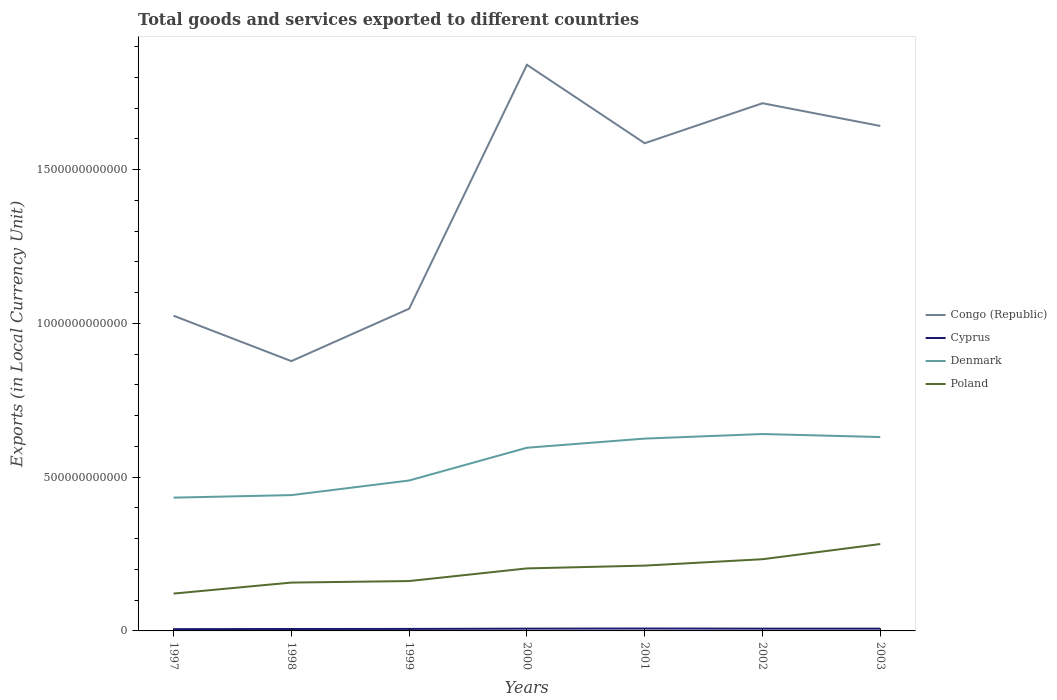How many different coloured lines are there?
Your answer should be compact. 4. Does the line corresponding to Denmark intersect with the line corresponding to Congo (Republic)?
Make the answer very short. No. Across all years, what is the maximum Amount of goods and services exports in Denmark?
Your answer should be compact. 4.33e+11. In which year was the Amount of goods and services exports in Cyprus maximum?
Make the answer very short. 1997. What is the total Amount of goods and services exports in Cyprus in the graph?
Provide a succinct answer. -1.27e+09. What is the difference between the highest and the second highest Amount of goods and services exports in Denmark?
Keep it short and to the point. 2.07e+11. What is the difference between two consecutive major ticks on the Y-axis?
Provide a succinct answer. 5.00e+11. Are the values on the major ticks of Y-axis written in scientific E-notation?
Keep it short and to the point. No. Where does the legend appear in the graph?
Provide a short and direct response. Center right. How many legend labels are there?
Your answer should be compact. 4. What is the title of the graph?
Your response must be concise. Total goods and services exported to different countries. Does "Pakistan" appear as one of the legend labels in the graph?
Ensure brevity in your answer.  No. What is the label or title of the X-axis?
Your answer should be compact. Years. What is the label or title of the Y-axis?
Offer a very short reply. Exports (in Local Currency Unit). What is the Exports (in Local Currency Unit) in Congo (Republic) in 1997?
Your answer should be very brief. 1.02e+12. What is the Exports (in Local Currency Unit) of Cyprus in 1997?
Offer a terse response. 5.79e+09. What is the Exports (in Local Currency Unit) of Denmark in 1997?
Offer a very short reply. 4.33e+11. What is the Exports (in Local Currency Unit) in Poland in 1997?
Your answer should be compact. 1.21e+11. What is the Exports (in Local Currency Unit) of Congo (Republic) in 1998?
Your answer should be very brief. 8.77e+11. What is the Exports (in Local Currency Unit) of Cyprus in 1998?
Keep it short and to the point. 6.22e+09. What is the Exports (in Local Currency Unit) in Denmark in 1998?
Your response must be concise. 4.42e+11. What is the Exports (in Local Currency Unit) of Poland in 1998?
Give a very brief answer. 1.57e+11. What is the Exports (in Local Currency Unit) in Congo (Republic) in 1999?
Provide a short and direct response. 1.05e+12. What is the Exports (in Local Currency Unit) in Cyprus in 1999?
Provide a succinct answer. 6.51e+09. What is the Exports (in Local Currency Unit) of Denmark in 1999?
Give a very brief answer. 4.89e+11. What is the Exports (in Local Currency Unit) in Poland in 1999?
Your answer should be compact. 1.62e+11. What is the Exports (in Local Currency Unit) in Congo (Republic) in 2000?
Offer a terse response. 1.84e+12. What is the Exports (in Local Currency Unit) of Cyprus in 2000?
Your answer should be very brief. 7.41e+09. What is the Exports (in Local Currency Unit) in Denmark in 2000?
Your answer should be compact. 5.96e+11. What is the Exports (in Local Currency Unit) of Poland in 2000?
Offer a very short reply. 2.03e+11. What is the Exports (in Local Currency Unit) in Congo (Republic) in 2001?
Provide a succinct answer. 1.59e+12. What is the Exports (in Local Currency Unit) in Cyprus in 2001?
Your answer should be compact. 7.79e+09. What is the Exports (in Local Currency Unit) in Denmark in 2001?
Offer a very short reply. 6.25e+11. What is the Exports (in Local Currency Unit) in Poland in 2001?
Make the answer very short. 2.12e+11. What is the Exports (in Local Currency Unit) in Congo (Republic) in 2002?
Your answer should be very brief. 1.72e+12. What is the Exports (in Local Currency Unit) in Cyprus in 2002?
Your answer should be very brief. 7.41e+09. What is the Exports (in Local Currency Unit) of Denmark in 2002?
Provide a succinct answer. 6.40e+11. What is the Exports (in Local Currency Unit) of Poland in 2002?
Your answer should be compact. 2.33e+11. What is the Exports (in Local Currency Unit) of Congo (Republic) in 2003?
Offer a terse response. 1.64e+12. What is the Exports (in Local Currency Unit) of Cyprus in 2003?
Provide a succinct answer. 7.42e+09. What is the Exports (in Local Currency Unit) of Denmark in 2003?
Make the answer very short. 6.30e+11. What is the Exports (in Local Currency Unit) in Poland in 2003?
Keep it short and to the point. 2.82e+11. Across all years, what is the maximum Exports (in Local Currency Unit) of Congo (Republic)?
Keep it short and to the point. 1.84e+12. Across all years, what is the maximum Exports (in Local Currency Unit) of Cyprus?
Offer a terse response. 7.79e+09. Across all years, what is the maximum Exports (in Local Currency Unit) of Denmark?
Your answer should be very brief. 6.40e+11. Across all years, what is the maximum Exports (in Local Currency Unit) of Poland?
Your answer should be compact. 2.82e+11. Across all years, what is the minimum Exports (in Local Currency Unit) of Congo (Republic)?
Provide a succinct answer. 8.77e+11. Across all years, what is the minimum Exports (in Local Currency Unit) of Cyprus?
Offer a terse response. 5.79e+09. Across all years, what is the minimum Exports (in Local Currency Unit) in Denmark?
Offer a terse response. 4.33e+11. Across all years, what is the minimum Exports (in Local Currency Unit) in Poland?
Make the answer very short. 1.21e+11. What is the total Exports (in Local Currency Unit) of Congo (Republic) in the graph?
Offer a terse response. 9.73e+12. What is the total Exports (in Local Currency Unit) of Cyprus in the graph?
Your response must be concise. 4.86e+1. What is the total Exports (in Local Currency Unit) in Denmark in the graph?
Offer a very short reply. 3.86e+12. What is the total Exports (in Local Currency Unit) in Poland in the graph?
Your response must be concise. 1.37e+12. What is the difference between the Exports (in Local Currency Unit) of Congo (Republic) in 1997 and that in 1998?
Your answer should be very brief. 1.48e+11. What is the difference between the Exports (in Local Currency Unit) in Cyprus in 1997 and that in 1998?
Provide a succinct answer. -4.31e+08. What is the difference between the Exports (in Local Currency Unit) in Denmark in 1997 and that in 1998?
Ensure brevity in your answer.  -8.22e+09. What is the difference between the Exports (in Local Currency Unit) in Poland in 1997 and that in 1998?
Keep it short and to the point. -3.57e+1. What is the difference between the Exports (in Local Currency Unit) of Congo (Republic) in 1997 and that in 1999?
Make the answer very short. -2.28e+1. What is the difference between the Exports (in Local Currency Unit) of Cyprus in 1997 and that in 1999?
Offer a very short reply. -7.20e+08. What is the difference between the Exports (in Local Currency Unit) of Denmark in 1997 and that in 1999?
Keep it short and to the point. -5.57e+1. What is the difference between the Exports (in Local Currency Unit) of Poland in 1997 and that in 1999?
Make the answer very short. -4.07e+1. What is the difference between the Exports (in Local Currency Unit) in Congo (Republic) in 1997 and that in 2000?
Give a very brief answer. -8.16e+11. What is the difference between the Exports (in Local Currency Unit) in Cyprus in 1997 and that in 2000?
Make the answer very short. -1.62e+09. What is the difference between the Exports (in Local Currency Unit) in Denmark in 1997 and that in 2000?
Offer a very short reply. -1.62e+11. What is the difference between the Exports (in Local Currency Unit) of Poland in 1997 and that in 2000?
Give a very brief answer. -8.18e+1. What is the difference between the Exports (in Local Currency Unit) in Congo (Republic) in 1997 and that in 2001?
Ensure brevity in your answer.  -5.61e+11. What is the difference between the Exports (in Local Currency Unit) of Cyprus in 1997 and that in 2001?
Offer a very short reply. -1.99e+09. What is the difference between the Exports (in Local Currency Unit) of Denmark in 1997 and that in 2001?
Offer a terse response. -1.92e+11. What is the difference between the Exports (in Local Currency Unit) of Poland in 1997 and that in 2001?
Offer a very short reply. -9.09e+1. What is the difference between the Exports (in Local Currency Unit) in Congo (Republic) in 1997 and that in 2002?
Keep it short and to the point. -6.91e+11. What is the difference between the Exports (in Local Currency Unit) of Cyprus in 1997 and that in 2002?
Give a very brief answer. -1.62e+09. What is the difference between the Exports (in Local Currency Unit) of Denmark in 1997 and that in 2002?
Your response must be concise. -2.07e+11. What is the difference between the Exports (in Local Currency Unit) of Poland in 1997 and that in 2002?
Your answer should be very brief. -1.12e+11. What is the difference between the Exports (in Local Currency Unit) of Congo (Republic) in 1997 and that in 2003?
Your answer should be compact. -6.17e+11. What is the difference between the Exports (in Local Currency Unit) of Cyprus in 1997 and that in 2003?
Your answer should be compact. -1.63e+09. What is the difference between the Exports (in Local Currency Unit) in Denmark in 1997 and that in 2003?
Provide a short and direct response. -1.97e+11. What is the difference between the Exports (in Local Currency Unit) in Poland in 1997 and that in 2003?
Offer a terse response. -1.61e+11. What is the difference between the Exports (in Local Currency Unit) in Congo (Republic) in 1998 and that in 1999?
Your response must be concise. -1.70e+11. What is the difference between the Exports (in Local Currency Unit) of Cyprus in 1998 and that in 1999?
Offer a very short reply. -2.89e+08. What is the difference between the Exports (in Local Currency Unit) of Denmark in 1998 and that in 1999?
Provide a succinct answer. -4.75e+1. What is the difference between the Exports (in Local Currency Unit) of Poland in 1998 and that in 1999?
Keep it short and to the point. -4.95e+09. What is the difference between the Exports (in Local Currency Unit) in Congo (Republic) in 1998 and that in 2000?
Keep it short and to the point. -9.64e+11. What is the difference between the Exports (in Local Currency Unit) of Cyprus in 1998 and that in 2000?
Offer a very short reply. -1.19e+09. What is the difference between the Exports (in Local Currency Unit) of Denmark in 1998 and that in 2000?
Your answer should be very brief. -1.54e+11. What is the difference between the Exports (in Local Currency Unit) in Poland in 1998 and that in 2000?
Your response must be concise. -4.61e+1. What is the difference between the Exports (in Local Currency Unit) in Congo (Republic) in 1998 and that in 2001?
Your answer should be very brief. -7.09e+11. What is the difference between the Exports (in Local Currency Unit) of Cyprus in 1998 and that in 2001?
Your answer should be compact. -1.56e+09. What is the difference between the Exports (in Local Currency Unit) in Denmark in 1998 and that in 2001?
Your answer should be very brief. -1.84e+11. What is the difference between the Exports (in Local Currency Unit) in Poland in 1998 and that in 2001?
Keep it short and to the point. -5.52e+1. What is the difference between the Exports (in Local Currency Unit) of Congo (Republic) in 1998 and that in 2002?
Your answer should be very brief. -8.39e+11. What is the difference between the Exports (in Local Currency Unit) in Cyprus in 1998 and that in 2002?
Your answer should be very brief. -1.19e+09. What is the difference between the Exports (in Local Currency Unit) of Denmark in 1998 and that in 2002?
Give a very brief answer. -1.99e+11. What is the difference between the Exports (in Local Currency Unit) of Poland in 1998 and that in 2002?
Provide a succinct answer. -7.59e+1. What is the difference between the Exports (in Local Currency Unit) of Congo (Republic) in 1998 and that in 2003?
Keep it short and to the point. -7.65e+11. What is the difference between the Exports (in Local Currency Unit) of Cyprus in 1998 and that in 2003?
Offer a terse response. -1.20e+09. What is the difference between the Exports (in Local Currency Unit) in Denmark in 1998 and that in 2003?
Offer a terse response. -1.89e+11. What is the difference between the Exports (in Local Currency Unit) in Poland in 1998 and that in 2003?
Make the answer very short. -1.25e+11. What is the difference between the Exports (in Local Currency Unit) in Congo (Republic) in 1999 and that in 2000?
Your response must be concise. -7.93e+11. What is the difference between the Exports (in Local Currency Unit) in Cyprus in 1999 and that in 2000?
Offer a terse response. -9.00e+08. What is the difference between the Exports (in Local Currency Unit) in Denmark in 1999 and that in 2000?
Your response must be concise. -1.07e+11. What is the difference between the Exports (in Local Currency Unit) of Poland in 1999 and that in 2000?
Your answer should be very brief. -4.11e+1. What is the difference between the Exports (in Local Currency Unit) in Congo (Republic) in 1999 and that in 2001?
Your answer should be very brief. -5.38e+11. What is the difference between the Exports (in Local Currency Unit) of Cyprus in 1999 and that in 2001?
Offer a terse response. -1.27e+09. What is the difference between the Exports (in Local Currency Unit) in Denmark in 1999 and that in 2001?
Provide a succinct answer. -1.36e+11. What is the difference between the Exports (in Local Currency Unit) of Poland in 1999 and that in 2001?
Your answer should be very brief. -5.02e+1. What is the difference between the Exports (in Local Currency Unit) in Congo (Republic) in 1999 and that in 2002?
Ensure brevity in your answer.  -6.68e+11. What is the difference between the Exports (in Local Currency Unit) in Cyprus in 1999 and that in 2002?
Make the answer very short. -8.99e+08. What is the difference between the Exports (in Local Currency Unit) of Denmark in 1999 and that in 2002?
Ensure brevity in your answer.  -1.51e+11. What is the difference between the Exports (in Local Currency Unit) of Poland in 1999 and that in 2002?
Give a very brief answer. -7.10e+1. What is the difference between the Exports (in Local Currency Unit) of Congo (Republic) in 1999 and that in 2003?
Keep it short and to the point. -5.94e+11. What is the difference between the Exports (in Local Currency Unit) of Cyprus in 1999 and that in 2003?
Ensure brevity in your answer.  -9.07e+08. What is the difference between the Exports (in Local Currency Unit) in Denmark in 1999 and that in 2003?
Your response must be concise. -1.41e+11. What is the difference between the Exports (in Local Currency Unit) of Poland in 1999 and that in 2003?
Provide a succinct answer. -1.20e+11. What is the difference between the Exports (in Local Currency Unit) of Congo (Republic) in 2000 and that in 2001?
Ensure brevity in your answer.  2.55e+11. What is the difference between the Exports (in Local Currency Unit) of Cyprus in 2000 and that in 2001?
Offer a terse response. -3.75e+08. What is the difference between the Exports (in Local Currency Unit) of Denmark in 2000 and that in 2001?
Ensure brevity in your answer.  -2.97e+1. What is the difference between the Exports (in Local Currency Unit) in Poland in 2000 and that in 2001?
Provide a short and direct response. -9.07e+09. What is the difference between the Exports (in Local Currency Unit) of Congo (Republic) in 2000 and that in 2002?
Ensure brevity in your answer.  1.25e+11. What is the difference between the Exports (in Local Currency Unit) in Cyprus in 2000 and that in 2002?
Provide a short and direct response. 6.50e+05. What is the difference between the Exports (in Local Currency Unit) in Denmark in 2000 and that in 2002?
Keep it short and to the point. -4.46e+1. What is the difference between the Exports (in Local Currency Unit) in Poland in 2000 and that in 2002?
Your answer should be very brief. -2.98e+1. What is the difference between the Exports (in Local Currency Unit) in Congo (Republic) in 2000 and that in 2003?
Give a very brief answer. 1.99e+11. What is the difference between the Exports (in Local Currency Unit) of Cyprus in 2000 and that in 2003?
Your answer should be very brief. -7.16e+06. What is the difference between the Exports (in Local Currency Unit) of Denmark in 2000 and that in 2003?
Provide a succinct answer. -3.48e+1. What is the difference between the Exports (in Local Currency Unit) in Poland in 2000 and that in 2003?
Your response must be concise. -7.92e+1. What is the difference between the Exports (in Local Currency Unit) of Congo (Republic) in 2001 and that in 2002?
Ensure brevity in your answer.  -1.30e+11. What is the difference between the Exports (in Local Currency Unit) in Cyprus in 2001 and that in 2002?
Your answer should be very brief. 3.75e+08. What is the difference between the Exports (in Local Currency Unit) in Denmark in 2001 and that in 2002?
Offer a terse response. -1.49e+1. What is the difference between the Exports (in Local Currency Unit) of Poland in 2001 and that in 2002?
Keep it short and to the point. -2.08e+1. What is the difference between the Exports (in Local Currency Unit) in Congo (Republic) in 2001 and that in 2003?
Provide a succinct answer. -5.62e+1. What is the difference between the Exports (in Local Currency Unit) of Cyprus in 2001 and that in 2003?
Your answer should be very brief. 3.68e+08. What is the difference between the Exports (in Local Currency Unit) of Denmark in 2001 and that in 2003?
Make the answer very short. -5.06e+09. What is the difference between the Exports (in Local Currency Unit) in Poland in 2001 and that in 2003?
Your response must be concise. -7.01e+1. What is the difference between the Exports (in Local Currency Unit) of Congo (Republic) in 2002 and that in 2003?
Keep it short and to the point. 7.39e+1. What is the difference between the Exports (in Local Currency Unit) in Cyprus in 2002 and that in 2003?
Offer a terse response. -7.81e+06. What is the difference between the Exports (in Local Currency Unit) of Denmark in 2002 and that in 2003?
Give a very brief answer. 9.83e+09. What is the difference between the Exports (in Local Currency Unit) of Poland in 2002 and that in 2003?
Provide a succinct answer. -4.93e+1. What is the difference between the Exports (in Local Currency Unit) in Congo (Republic) in 1997 and the Exports (in Local Currency Unit) in Cyprus in 1998?
Your answer should be very brief. 1.02e+12. What is the difference between the Exports (in Local Currency Unit) in Congo (Republic) in 1997 and the Exports (in Local Currency Unit) in Denmark in 1998?
Make the answer very short. 5.83e+11. What is the difference between the Exports (in Local Currency Unit) of Congo (Republic) in 1997 and the Exports (in Local Currency Unit) of Poland in 1998?
Your response must be concise. 8.68e+11. What is the difference between the Exports (in Local Currency Unit) in Cyprus in 1997 and the Exports (in Local Currency Unit) in Denmark in 1998?
Offer a terse response. -4.36e+11. What is the difference between the Exports (in Local Currency Unit) of Cyprus in 1997 and the Exports (in Local Currency Unit) of Poland in 1998?
Ensure brevity in your answer.  -1.51e+11. What is the difference between the Exports (in Local Currency Unit) in Denmark in 1997 and the Exports (in Local Currency Unit) in Poland in 1998?
Your response must be concise. 2.76e+11. What is the difference between the Exports (in Local Currency Unit) of Congo (Republic) in 1997 and the Exports (in Local Currency Unit) of Cyprus in 1999?
Give a very brief answer. 1.02e+12. What is the difference between the Exports (in Local Currency Unit) in Congo (Republic) in 1997 and the Exports (in Local Currency Unit) in Denmark in 1999?
Provide a short and direct response. 5.36e+11. What is the difference between the Exports (in Local Currency Unit) of Congo (Republic) in 1997 and the Exports (in Local Currency Unit) of Poland in 1999?
Your response must be concise. 8.63e+11. What is the difference between the Exports (in Local Currency Unit) of Cyprus in 1997 and the Exports (in Local Currency Unit) of Denmark in 1999?
Provide a short and direct response. -4.83e+11. What is the difference between the Exports (in Local Currency Unit) of Cyprus in 1997 and the Exports (in Local Currency Unit) of Poland in 1999?
Your response must be concise. -1.56e+11. What is the difference between the Exports (in Local Currency Unit) in Denmark in 1997 and the Exports (in Local Currency Unit) in Poland in 1999?
Give a very brief answer. 2.71e+11. What is the difference between the Exports (in Local Currency Unit) in Congo (Republic) in 1997 and the Exports (in Local Currency Unit) in Cyprus in 2000?
Your answer should be compact. 1.02e+12. What is the difference between the Exports (in Local Currency Unit) in Congo (Republic) in 1997 and the Exports (in Local Currency Unit) in Denmark in 2000?
Ensure brevity in your answer.  4.29e+11. What is the difference between the Exports (in Local Currency Unit) in Congo (Republic) in 1997 and the Exports (in Local Currency Unit) in Poland in 2000?
Provide a succinct answer. 8.22e+11. What is the difference between the Exports (in Local Currency Unit) in Cyprus in 1997 and the Exports (in Local Currency Unit) in Denmark in 2000?
Provide a short and direct response. -5.90e+11. What is the difference between the Exports (in Local Currency Unit) in Cyprus in 1997 and the Exports (in Local Currency Unit) in Poland in 2000?
Provide a short and direct response. -1.97e+11. What is the difference between the Exports (in Local Currency Unit) of Denmark in 1997 and the Exports (in Local Currency Unit) of Poland in 2000?
Keep it short and to the point. 2.30e+11. What is the difference between the Exports (in Local Currency Unit) in Congo (Republic) in 1997 and the Exports (in Local Currency Unit) in Cyprus in 2001?
Provide a short and direct response. 1.02e+12. What is the difference between the Exports (in Local Currency Unit) in Congo (Republic) in 1997 and the Exports (in Local Currency Unit) in Denmark in 2001?
Keep it short and to the point. 4.00e+11. What is the difference between the Exports (in Local Currency Unit) of Congo (Republic) in 1997 and the Exports (in Local Currency Unit) of Poland in 2001?
Your response must be concise. 8.13e+11. What is the difference between the Exports (in Local Currency Unit) of Cyprus in 1997 and the Exports (in Local Currency Unit) of Denmark in 2001?
Your answer should be compact. -6.20e+11. What is the difference between the Exports (in Local Currency Unit) in Cyprus in 1997 and the Exports (in Local Currency Unit) in Poland in 2001?
Provide a short and direct response. -2.07e+11. What is the difference between the Exports (in Local Currency Unit) of Denmark in 1997 and the Exports (in Local Currency Unit) of Poland in 2001?
Give a very brief answer. 2.21e+11. What is the difference between the Exports (in Local Currency Unit) in Congo (Republic) in 1997 and the Exports (in Local Currency Unit) in Cyprus in 2002?
Your response must be concise. 1.02e+12. What is the difference between the Exports (in Local Currency Unit) of Congo (Republic) in 1997 and the Exports (in Local Currency Unit) of Denmark in 2002?
Offer a terse response. 3.85e+11. What is the difference between the Exports (in Local Currency Unit) of Congo (Republic) in 1997 and the Exports (in Local Currency Unit) of Poland in 2002?
Offer a very short reply. 7.92e+11. What is the difference between the Exports (in Local Currency Unit) in Cyprus in 1997 and the Exports (in Local Currency Unit) in Denmark in 2002?
Give a very brief answer. -6.34e+11. What is the difference between the Exports (in Local Currency Unit) in Cyprus in 1997 and the Exports (in Local Currency Unit) in Poland in 2002?
Offer a terse response. -2.27e+11. What is the difference between the Exports (in Local Currency Unit) of Denmark in 1997 and the Exports (in Local Currency Unit) of Poland in 2002?
Your response must be concise. 2.00e+11. What is the difference between the Exports (in Local Currency Unit) in Congo (Republic) in 1997 and the Exports (in Local Currency Unit) in Cyprus in 2003?
Provide a succinct answer. 1.02e+12. What is the difference between the Exports (in Local Currency Unit) in Congo (Republic) in 1997 and the Exports (in Local Currency Unit) in Denmark in 2003?
Your response must be concise. 3.94e+11. What is the difference between the Exports (in Local Currency Unit) in Congo (Republic) in 1997 and the Exports (in Local Currency Unit) in Poland in 2003?
Make the answer very short. 7.42e+11. What is the difference between the Exports (in Local Currency Unit) in Cyprus in 1997 and the Exports (in Local Currency Unit) in Denmark in 2003?
Provide a short and direct response. -6.25e+11. What is the difference between the Exports (in Local Currency Unit) of Cyprus in 1997 and the Exports (in Local Currency Unit) of Poland in 2003?
Keep it short and to the point. -2.77e+11. What is the difference between the Exports (in Local Currency Unit) in Denmark in 1997 and the Exports (in Local Currency Unit) in Poland in 2003?
Make the answer very short. 1.51e+11. What is the difference between the Exports (in Local Currency Unit) in Congo (Republic) in 1998 and the Exports (in Local Currency Unit) in Cyprus in 1999?
Make the answer very short. 8.71e+11. What is the difference between the Exports (in Local Currency Unit) in Congo (Republic) in 1998 and the Exports (in Local Currency Unit) in Denmark in 1999?
Your answer should be compact. 3.88e+11. What is the difference between the Exports (in Local Currency Unit) in Congo (Republic) in 1998 and the Exports (in Local Currency Unit) in Poland in 1999?
Your answer should be very brief. 7.15e+11. What is the difference between the Exports (in Local Currency Unit) in Cyprus in 1998 and the Exports (in Local Currency Unit) in Denmark in 1999?
Your answer should be compact. -4.83e+11. What is the difference between the Exports (in Local Currency Unit) of Cyprus in 1998 and the Exports (in Local Currency Unit) of Poland in 1999?
Your answer should be very brief. -1.56e+11. What is the difference between the Exports (in Local Currency Unit) of Denmark in 1998 and the Exports (in Local Currency Unit) of Poland in 1999?
Your response must be concise. 2.79e+11. What is the difference between the Exports (in Local Currency Unit) in Congo (Republic) in 1998 and the Exports (in Local Currency Unit) in Cyprus in 2000?
Your response must be concise. 8.70e+11. What is the difference between the Exports (in Local Currency Unit) in Congo (Republic) in 1998 and the Exports (in Local Currency Unit) in Denmark in 2000?
Your response must be concise. 2.82e+11. What is the difference between the Exports (in Local Currency Unit) of Congo (Republic) in 1998 and the Exports (in Local Currency Unit) of Poland in 2000?
Keep it short and to the point. 6.74e+11. What is the difference between the Exports (in Local Currency Unit) in Cyprus in 1998 and the Exports (in Local Currency Unit) in Denmark in 2000?
Provide a succinct answer. -5.89e+11. What is the difference between the Exports (in Local Currency Unit) of Cyprus in 1998 and the Exports (in Local Currency Unit) of Poland in 2000?
Ensure brevity in your answer.  -1.97e+11. What is the difference between the Exports (in Local Currency Unit) of Denmark in 1998 and the Exports (in Local Currency Unit) of Poland in 2000?
Give a very brief answer. 2.38e+11. What is the difference between the Exports (in Local Currency Unit) of Congo (Republic) in 1998 and the Exports (in Local Currency Unit) of Cyprus in 2001?
Your response must be concise. 8.69e+11. What is the difference between the Exports (in Local Currency Unit) in Congo (Republic) in 1998 and the Exports (in Local Currency Unit) in Denmark in 2001?
Your answer should be very brief. 2.52e+11. What is the difference between the Exports (in Local Currency Unit) of Congo (Republic) in 1998 and the Exports (in Local Currency Unit) of Poland in 2001?
Offer a terse response. 6.65e+11. What is the difference between the Exports (in Local Currency Unit) in Cyprus in 1998 and the Exports (in Local Currency Unit) in Denmark in 2001?
Provide a succinct answer. -6.19e+11. What is the difference between the Exports (in Local Currency Unit) in Cyprus in 1998 and the Exports (in Local Currency Unit) in Poland in 2001?
Offer a terse response. -2.06e+11. What is the difference between the Exports (in Local Currency Unit) of Denmark in 1998 and the Exports (in Local Currency Unit) of Poland in 2001?
Give a very brief answer. 2.29e+11. What is the difference between the Exports (in Local Currency Unit) of Congo (Republic) in 1998 and the Exports (in Local Currency Unit) of Cyprus in 2002?
Offer a very short reply. 8.70e+11. What is the difference between the Exports (in Local Currency Unit) in Congo (Republic) in 1998 and the Exports (in Local Currency Unit) in Denmark in 2002?
Offer a terse response. 2.37e+11. What is the difference between the Exports (in Local Currency Unit) in Congo (Republic) in 1998 and the Exports (in Local Currency Unit) in Poland in 2002?
Keep it short and to the point. 6.44e+11. What is the difference between the Exports (in Local Currency Unit) of Cyprus in 1998 and the Exports (in Local Currency Unit) of Denmark in 2002?
Make the answer very short. -6.34e+11. What is the difference between the Exports (in Local Currency Unit) in Cyprus in 1998 and the Exports (in Local Currency Unit) in Poland in 2002?
Your answer should be very brief. -2.27e+11. What is the difference between the Exports (in Local Currency Unit) of Denmark in 1998 and the Exports (in Local Currency Unit) of Poland in 2002?
Offer a very short reply. 2.08e+11. What is the difference between the Exports (in Local Currency Unit) of Congo (Republic) in 1998 and the Exports (in Local Currency Unit) of Cyprus in 2003?
Your response must be concise. 8.70e+11. What is the difference between the Exports (in Local Currency Unit) in Congo (Republic) in 1998 and the Exports (in Local Currency Unit) in Denmark in 2003?
Your response must be concise. 2.47e+11. What is the difference between the Exports (in Local Currency Unit) of Congo (Republic) in 1998 and the Exports (in Local Currency Unit) of Poland in 2003?
Provide a short and direct response. 5.95e+11. What is the difference between the Exports (in Local Currency Unit) of Cyprus in 1998 and the Exports (in Local Currency Unit) of Denmark in 2003?
Your response must be concise. -6.24e+11. What is the difference between the Exports (in Local Currency Unit) of Cyprus in 1998 and the Exports (in Local Currency Unit) of Poland in 2003?
Provide a succinct answer. -2.76e+11. What is the difference between the Exports (in Local Currency Unit) of Denmark in 1998 and the Exports (in Local Currency Unit) of Poland in 2003?
Give a very brief answer. 1.59e+11. What is the difference between the Exports (in Local Currency Unit) of Congo (Republic) in 1999 and the Exports (in Local Currency Unit) of Cyprus in 2000?
Provide a short and direct response. 1.04e+12. What is the difference between the Exports (in Local Currency Unit) in Congo (Republic) in 1999 and the Exports (in Local Currency Unit) in Denmark in 2000?
Your answer should be compact. 4.52e+11. What is the difference between the Exports (in Local Currency Unit) in Congo (Republic) in 1999 and the Exports (in Local Currency Unit) in Poland in 2000?
Offer a terse response. 8.44e+11. What is the difference between the Exports (in Local Currency Unit) in Cyprus in 1999 and the Exports (in Local Currency Unit) in Denmark in 2000?
Give a very brief answer. -5.89e+11. What is the difference between the Exports (in Local Currency Unit) of Cyprus in 1999 and the Exports (in Local Currency Unit) of Poland in 2000?
Your answer should be very brief. -1.97e+11. What is the difference between the Exports (in Local Currency Unit) of Denmark in 1999 and the Exports (in Local Currency Unit) of Poland in 2000?
Your answer should be compact. 2.86e+11. What is the difference between the Exports (in Local Currency Unit) in Congo (Republic) in 1999 and the Exports (in Local Currency Unit) in Cyprus in 2001?
Offer a terse response. 1.04e+12. What is the difference between the Exports (in Local Currency Unit) of Congo (Republic) in 1999 and the Exports (in Local Currency Unit) of Denmark in 2001?
Your response must be concise. 4.22e+11. What is the difference between the Exports (in Local Currency Unit) in Congo (Republic) in 1999 and the Exports (in Local Currency Unit) in Poland in 2001?
Make the answer very short. 8.35e+11. What is the difference between the Exports (in Local Currency Unit) in Cyprus in 1999 and the Exports (in Local Currency Unit) in Denmark in 2001?
Offer a terse response. -6.19e+11. What is the difference between the Exports (in Local Currency Unit) in Cyprus in 1999 and the Exports (in Local Currency Unit) in Poland in 2001?
Ensure brevity in your answer.  -2.06e+11. What is the difference between the Exports (in Local Currency Unit) of Denmark in 1999 and the Exports (in Local Currency Unit) of Poland in 2001?
Give a very brief answer. 2.77e+11. What is the difference between the Exports (in Local Currency Unit) in Congo (Republic) in 1999 and the Exports (in Local Currency Unit) in Cyprus in 2002?
Provide a short and direct response. 1.04e+12. What is the difference between the Exports (in Local Currency Unit) of Congo (Republic) in 1999 and the Exports (in Local Currency Unit) of Denmark in 2002?
Give a very brief answer. 4.07e+11. What is the difference between the Exports (in Local Currency Unit) in Congo (Republic) in 1999 and the Exports (in Local Currency Unit) in Poland in 2002?
Ensure brevity in your answer.  8.15e+11. What is the difference between the Exports (in Local Currency Unit) of Cyprus in 1999 and the Exports (in Local Currency Unit) of Denmark in 2002?
Give a very brief answer. -6.34e+11. What is the difference between the Exports (in Local Currency Unit) in Cyprus in 1999 and the Exports (in Local Currency Unit) in Poland in 2002?
Your response must be concise. -2.27e+11. What is the difference between the Exports (in Local Currency Unit) of Denmark in 1999 and the Exports (in Local Currency Unit) of Poland in 2002?
Your response must be concise. 2.56e+11. What is the difference between the Exports (in Local Currency Unit) in Congo (Republic) in 1999 and the Exports (in Local Currency Unit) in Cyprus in 2003?
Provide a short and direct response. 1.04e+12. What is the difference between the Exports (in Local Currency Unit) of Congo (Republic) in 1999 and the Exports (in Local Currency Unit) of Denmark in 2003?
Keep it short and to the point. 4.17e+11. What is the difference between the Exports (in Local Currency Unit) in Congo (Republic) in 1999 and the Exports (in Local Currency Unit) in Poland in 2003?
Your response must be concise. 7.65e+11. What is the difference between the Exports (in Local Currency Unit) in Cyprus in 1999 and the Exports (in Local Currency Unit) in Denmark in 2003?
Ensure brevity in your answer.  -6.24e+11. What is the difference between the Exports (in Local Currency Unit) in Cyprus in 1999 and the Exports (in Local Currency Unit) in Poland in 2003?
Give a very brief answer. -2.76e+11. What is the difference between the Exports (in Local Currency Unit) of Denmark in 1999 and the Exports (in Local Currency Unit) of Poland in 2003?
Offer a terse response. 2.07e+11. What is the difference between the Exports (in Local Currency Unit) of Congo (Republic) in 2000 and the Exports (in Local Currency Unit) of Cyprus in 2001?
Offer a terse response. 1.83e+12. What is the difference between the Exports (in Local Currency Unit) of Congo (Republic) in 2000 and the Exports (in Local Currency Unit) of Denmark in 2001?
Provide a short and direct response. 1.22e+12. What is the difference between the Exports (in Local Currency Unit) in Congo (Republic) in 2000 and the Exports (in Local Currency Unit) in Poland in 2001?
Your response must be concise. 1.63e+12. What is the difference between the Exports (in Local Currency Unit) in Cyprus in 2000 and the Exports (in Local Currency Unit) in Denmark in 2001?
Provide a succinct answer. -6.18e+11. What is the difference between the Exports (in Local Currency Unit) of Cyprus in 2000 and the Exports (in Local Currency Unit) of Poland in 2001?
Provide a succinct answer. -2.05e+11. What is the difference between the Exports (in Local Currency Unit) in Denmark in 2000 and the Exports (in Local Currency Unit) in Poland in 2001?
Make the answer very short. 3.83e+11. What is the difference between the Exports (in Local Currency Unit) in Congo (Republic) in 2000 and the Exports (in Local Currency Unit) in Cyprus in 2002?
Keep it short and to the point. 1.83e+12. What is the difference between the Exports (in Local Currency Unit) in Congo (Republic) in 2000 and the Exports (in Local Currency Unit) in Denmark in 2002?
Provide a short and direct response. 1.20e+12. What is the difference between the Exports (in Local Currency Unit) of Congo (Republic) in 2000 and the Exports (in Local Currency Unit) of Poland in 2002?
Provide a short and direct response. 1.61e+12. What is the difference between the Exports (in Local Currency Unit) in Cyprus in 2000 and the Exports (in Local Currency Unit) in Denmark in 2002?
Offer a terse response. -6.33e+11. What is the difference between the Exports (in Local Currency Unit) of Cyprus in 2000 and the Exports (in Local Currency Unit) of Poland in 2002?
Keep it short and to the point. -2.26e+11. What is the difference between the Exports (in Local Currency Unit) in Denmark in 2000 and the Exports (in Local Currency Unit) in Poland in 2002?
Ensure brevity in your answer.  3.63e+11. What is the difference between the Exports (in Local Currency Unit) of Congo (Republic) in 2000 and the Exports (in Local Currency Unit) of Cyprus in 2003?
Give a very brief answer. 1.83e+12. What is the difference between the Exports (in Local Currency Unit) in Congo (Republic) in 2000 and the Exports (in Local Currency Unit) in Denmark in 2003?
Offer a terse response. 1.21e+12. What is the difference between the Exports (in Local Currency Unit) of Congo (Republic) in 2000 and the Exports (in Local Currency Unit) of Poland in 2003?
Offer a terse response. 1.56e+12. What is the difference between the Exports (in Local Currency Unit) of Cyprus in 2000 and the Exports (in Local Currency Unit) of Denmark in 2003?
Provide a short and direct response. -6.23e+11. What is the difference between the Exports (in Local Currency Unit) of Cyprus in 2000 and the Exports (in Local Currency Unit) of Poland in 2003?
Give a very brief answer. -2.75e+11. What is the difference between the Exports (in Local Currency Unit) in Denmark in 2000 and the Exports (in Local Currency Unit) in Poland in 2003?
Give a very brief answer. 3.13e+11. What is the difference between the Exports (in Local Currency Unit) in Congo (Republic) in 2001 and the Exports (in Local Currency Unit) in Cyprus in 2002?
Your answer should be compact. 1.58e+12. What is the difference between the Exports (in Local Currency Unit) in Congo (Republic) in 2001 and the Exports (in Local Currency Unit) in Denmark in 2002?
Provide a succinct answer. 9.46e+11. What is the difference between the Exports (in Local Currency Unit) of Congo (Republic) in 2001 and the Exports (in Local Currency Unit) of Poland in 2002?
Ensure brevity in your answer.  1.35e+12. What is the difference between the Exports (in Local Currency Unit) of Cyprus in 2001 and the Exports (in Local Currency Unit) of Denmark in 2002?
Provide a short and direct response. -6.32e+11. What is the difference between the Exports (in Local Currency Unit) of Cyprus in 2001 and the Exports (in Local Currency Unit) of Poland in 2002?
Ensure brevity in your answer.  -2.25e+11. What is the difference between the Exports (in Local Currency Unit) in Denmark in 2001 and the Exports (in Local Currency Unit) in Poland in 2002?
Ensure brevity in your answer.  3.92e+11. What is the difference between the Exports (in Local Currency Unit) in Congo (Republic) in 2001 and the Exports (in Local Currency Unit) in Cyprus in 2003?
Ensure brevity in your answer.  1.58e+12. What is the difference between the Exports (in Local Currency Unit) of Congo (Republic) in 2001 and the Exports (in Local Currency Unit) of Denmark in 2003?
Your answer should be very brief. 9.55e+11. What is the difference between the Exports (in Local Currency Unit) in Congo (Republic) in 2001 and the Exports (in Local Currency Unit) in Poland in 2003?
Your response must be concise. 1.30e+12. What is the difference between the Exports (in Local Currency Unit) of Cyprus in 2001 and the Exports (in Local Currency Unit) of Denmark in 2003?
Offer a terse response. -6.23e+11. What is the difference between the Exports (in Local Currency Unit) in Cyprus in 2001 and the Exports (in Local Currency Unit) in Poland in 2003?
Your response must be concise. -2.75e+11. What is the difference between the Exports (in Local Currency Unit) of Denmark in 2001 and the Exports (in Local Currency Unit) of Poland in 2003?
Provide a succinct answer. 3.43e+11. What is the difference between the Exports (in Local Currency Unit) in Congo (Republic) in 2002 and the Exports (in Local Currency Unit) in Cyprus in 2003?
Keep it short and to the point. 1.71e+12. What is the difference between the Exports (in Local Currency Unit) in Congo (Republic) in 2002 and the Exports (in Local Currency Unit) in Denmark in 2003?
Give a very brief answer. 1.09e+12. What is the difference between the Exports (in Local Currency Unit) in Congo (Republic) in 2002 and the Exports (in Local Currency Unit) in Poland in 2003?
Your answer should be very brief. 1.43e+12. What is the difference between the Exports (in Local Currency Unit) of Cyprus in 2002 and the Exports (in Local Currency Unit) of Denmark in 2003?
Your response must be concise. -6.23e+11. What is the difference between the Exports (in Local Currency Unit) of Cyprus in 2002 and the Exports (in Local Currency Unit) of Poland in 2003?
Your response must be concise. -2.75e+11. What is the difference between the Exports (in Local Currency Unit) of Denmark in 2002 and the Exports (in Local Currency Unit) of Poland in 2003?
Your answer should be compact. 3.58e+11. What is the average Exports (in Local Currency Unit) of Congo (Republic) per year?
Make the answer very short. 1.39e+12. What is the average Exports (in Local Currency Unit) of Cyprus per year?
Provide a succinct answer. 6.94e+09. What is the average Exports (in Local Currency Unit) of Denmark per year?
Keep it short and to the point. 5.51e+11. What is the average Exports (in Local Currency Unit) of Poland per year?
Provide a succinct answer. 1.96e+11. In the year 1997, what is the difference between the Exports (in Local Currency Unit) in Congo (Republic) and Exports (in Local Currency Unit) in Cyprus?
Provide a short and direct response. 1.02e+12. In the year 1997, what is the difference between the Exports (in Local Currency Unit) in Congo (Republic) and Exports (in Local Currency Unit) in Denmark?
Make the answer very short. 5.91e+11. In the year 1997, what is the difference between the Exports (in Local Currency Unit) of Congo (Republic) and Exports (in Local Currency Unit) of Poland?
Your answer should be very brief. 9.03e+11. In the year 1997, what is the difference between the Exports (in Local Currency Unit) in Cyprus and Exports (in Local Currency Unit) in Denmark?
Offer a very short reply. -4.28e+11. In the year 1997, what is the difference between the Exports (in Local Currency Unit) in Cyprus and Exports (in Local Currency Unit) in Poland?
Offer a very short reply. -1.16e+11. In the year 1997, what is the difference between the Exports (in Local Currency Unit) in Denmark and Exports (in Local Currency Unit) in Poland?
Offer a terse response. 3.12e+11. In the year 1998, what is the difference between the Exports (in Local Currency Unit) in Congo (Republic) and Exports (in Local Currency Unit) in Cyprus?
Keep it short and to the point. 8.71e+11. In the year 1998, what is the difference between the Exports (in Local Currency Unit) in Congo (Republic) and Exports (in Local Currency Unit) in Denmark?
Offer a very short reply. 4.36e+11. In the year 1998, what is the difference between the Exports (in Local Currency Unit) of Congo (Republic) and Exports (in Local Currency Unit) of Poland?
Offer a terse response. 7.20e+11. In the year 1998, what is the difference between the Exports (in Local Currency Unit) in Cyprus and Exports (in Local Currency Unit) in Denmark?
Offer a very short reply. -4.35e+11. In the year 1998, what is the difference between the Exports (in Local Currency Unit) in Cyprus and Exports (in Local Currency Unit) in Poland?
Offer a terse response. -1.51e+11. In the year 1998, what is the difference between the Exports (in Local Currency Unit) in Denmark and Exports (in Local Currency Unit) in Poland?
Keep it short and to the point. 2.84e+11. In the year 1999, what is the difference between the Exports (in Local Currency Unit) in Congo (Republic) and Exports (in Local Currency Unit) in Cyprus?
Give a very brief answer. 1.04e+12. In the year 1999, what is the difference between the Exports (in Local Currency Unit) of Congo (Republic) and Exports (in Local Currency Unit) of Denmark?
Ensure brevity in your answer.  5.59e+11. In the year 1999, what is the difference between the Exports (in Local Currency Unit) in Congo (Republic) and Exports (in Local Currency Unit) in Poland?
Keep it short and to the point. 8.86e+11. In the year 1999, what is the difference between the Exports (in Local Currency Unit) in Cyprus and Exports (in Local Currency Unit) in Denmark?
Provide a succinct answer. -4.83e+11. In the year 1999, what is the difference between the Exports (in Local Currency Unit) of Cyprus and Exports (in Local Currency Unit) of Poland?
Ensure brevity in your answer.  -1.56e+11. In the year 1999, what is the difference between the Exports (in Local Currency Unit) of Denmark and Exports (in Local Currency Unit) of Poland?
Provide a succinct answer. 3.27e+11. In the year 2000, what is the difference between the Exports (in Local Currency Unit) in Congo (Republic) and Exports (in Local Currency Unit) in Cyprus?
Offer a terse response. 1.83e+12. In the year 2000, what is the difference between the Exports (in Local Currency Unit) of Congo (Republic) and Exports (in Local Currency Unit) of Denmark?
Your answer should be very brief. 1.25e+12. In the year 2000, what is the difference between the Exports (in Local Currency Unit) in Congo (Republic) and Exports (in Local Currency Unit) in Poland?
Ensure brevity in your answer.  1.64e+12. In the year 2000, what is the difference between the Exports (in Local Currency Unit) of Cyprus and Exports (in Local Currency Unit) of Denmark?
Your response must be concise. -5.88e+11. In the year 2000, what is the difference between the Exports (in Local Currency Unit) in Cyprus and Exports (in Local Currency Unit) in Poland?
Provide a succinct answer. -1.96e+11. In the year 2000, what is the difference between the Exports (in Local Currency Unit) of Denmark and Exports (in Local Currency Unit) of Poland?
Your answer should be compact. 3.92e+11. In the year 2001, what is the difference between the Exports (in Local Currency Unit) of Congo (Republic) and Exports (in Local Currency Unit) of Cyprus?
Your response must be concise. 1.58e+12. In the year 2001, what is the difference between the Exports (in Local Currency Unit) in Congo (Republic) and Exports (in Local Currency Unit) in Denmark?
Make the answer very short. 9.60e+11. In the year 2001, what is the difference between the Exports (in Local Currency Unit) in Congo (Republic) and Exports (in Local Currency Unit) in Poland?
Provide a succinct answer. 1.37e+12. In the year 2001, what is the difference between the Exports (in Local Currency Unit) of Cyprus and Exports (in Local Currency Unit) of Denmark?
Keep it short and to the point. -6.18e+11. In the year 2001, what is the difference between the Exports (in Local Currency Unit) of Cyprus and Exports (in Local Currency Unit) of Poland?
Provide a succinct answer. -2.05e+11. In the year 2001, what is the difference between the Exports (in Local Currency Unit) in Denmark and Exports (in Local Currency Unit) in Poland?
Your answer should be very brief. 4.13e+11. In the year 2002, what is the difference between the Exports (in Local Currency Unit) in Congo (Republic) and Exports (in Local Currency Unit) in Cyprus?
Provide a succinct answer. 1.71e+12. In the year 2002, what is the difference between the Exports (in Local Currency Unit) of Congo (Republic) and Exports (in Local Currency Unit) of Denmark?
Your answer should be very brief. 1.08e+12. In the year 2002, what is the difference between the Exports (in Local Currency Unit) of Congo (Republic) and Exports (in Local Currency Unit) of Poland?
Give a very brief answer. 1.48e+12. In the year 2002, what is the difference between the Exports (in Local Currency Unit) in Cyprus and Exports (in Local Currency Unit) in Denmark?
Your answer should be compact. -6.33e+11. In the year 2002, what is the difference between the Exports (in Local Currency Unit) of Cyprus and Exports (in Local Currency Unit) of Poland?
Provide a short and direct response. -2.26e+11. In the year 2002, what is the difference between the Exports (in Local Currency Unit) of Denmark and Exports (in Local Currency Unit) of Poland?
Your response must be concise. 4.07e+11. In the year 2003, what is the difference between the Exports (in Local Currency Unit) of Congo (Republic) and Exports (in Local Currency Unit) of Cyprus?
Provide a succinct answer. 1.63e+12. In the year 2003, what is the difference between the Exports (in Local Currency Unit) in Congo (Republic) and Exports (in Local Currency Unit) in Denmark?
Offer a very short reply. 1.01e+12. In the year 2003, what is the difference between the Exports (in Local Currency Unit) in Congo (Republic) and Exports (in Local Currency Unit) in Poland?
Your answer should be very brief. 1.36e+12. In the year 2003, what is the difference between the Exports (in Local Currency Unit) of Cyprus and Exports (in Local Currency Unit) of Denmark?
Make the answer very short. -6.23e+11. In the year 2003, what is the difference between the Exports (in Local Currency Unit) in Cyprus and Exports (in Local Currency Unit) in Poland?
Give a very brief answer. -2.75e+11. In the year 2003, what is the difference between the Exports (in Local Currency Unit) in Denmark and Exports (in Local Currency Unit) in Poland?
Your answer should be very brief. 3.48e+11. What is the ratio of the Exports (in Local Currency Unit) of Congo (Republic) in 1997 to that in 1998?
Provide a short and direct response. 1.17. What is the ratio of the Exports (in Local Currency Unit) of Cyprus in 1997 to that in 1998?
Provide a short and direct response. 0.93. What is the ratio of the Exports (in Local Currency Unit) of Denmark in 1997 to that in 1998?
Your response must be concise. 0.98. What is the ratio of the Exports (in Local Currency Unit) in Poland in 1997 to that in 1998?
Make the answer very short. 0.77. What is the ratio of the Exports (in Local Currency Unit) in Congo (Republic) in 1997 to that in 1999?
Your answer should be very brief. 0.98. What is the ratio of the Exports (in Local Currency Unit) in Cyprus in 1997 to that in 1999?
Your response must be concise. 0.89. What is the ratio of the Exports (in Local Currency Unit) in Denmark in 1997 to that in 1999?
Offer a terse response. 0.89. What is the ratio of the Exports (in Local Currency Unit) in Poland in 1997 to that in 1999?
Your answer should be compact. 0.75. What is the ratio of the Exports (in Local Currency Unit) of Congo (Republic) in 1997 to that in 2000?
Offer a very short reply. 0.56. What is the ratio of the Exports (in Local Currency Unit) of Cyprus in 1997 to that in 2000?
Offer a very short reply. 0.78. What is the ratio of the Exports (in Local Currency Unit) in Denmark in 1997 to that in 2000?
Offer a very short reply. 0.73. What is the ratio of the Exports (in Local Currency Unit) of Poland in 1997 to that in 2000?
Your answer should be very brief. 0.6. What is the ratio of the Exports (in Local Currency Unit) of Congo (Republic) in 1997 to that in 2001?
Ensure brevity in your answer.  0.65. What is the ratio of the Exports (in Local Currency Unit) in Cyprus in 1997 to that in 2001?
Make the answer very short. 0.74. What is the ratio of the Exports (in Local Currency Unit) of Denmark in 1997 to that in 2001?
Keep it short and to the point. 0.69. What is the ratio of the Exports (in Local Currency Unit) of Poland in 1997 to that in 2001?
Provide a succinct answer. 0.57. What is the ratio of the Exports (in Local Currency Unit) in Congo (Republic) in 1997 to that in 2002?
Your response must be concise. 0.6. What is the ratio of the Exports (in Local Currency Unit) of Cyprus in 1997 to that in 2002?
Provide a succinct answer. 0.78. What is the ratio of the Exports (in Local Currency Unit) in Denmark in 1997 to that in 2002?
Offer a very short reply. 0.68. What is the ratio of the Exports (in Local Currency Unit) of Poland in 1997 to that in 2002?
Your response must be concise. 0.52. What is the ratio of the Exports (in Local Currency Unit) in Congo (Republic) in 1997 to that in 2003?
Your answer should be very brief. 0.62. What is the ratio of the Exports (in Local Currency Unit) in Cyprus in 1997 to that in 2003?
Make the answer very short. 0.78. What is the ratio of the Exports (in Local Currency Unit) of Denmark in 1997 to that in 2003?
Give a very brief answer. 0.69. What is the ratio of the Exports (in Local Currency Unit) of Poland in 1997 to that in 2003?
Make the answer very short. 0.43. What is the ratio of the Exports (in Local Currency Unit) of Congo (Republic) in 1998 to that in 1999?
Keep it short and to the point. 0.84. What is the ratio of the Exports (in Local Currency Unit) in Cyprus in 1998 to that in 1999?
Offer a very short reply. 0.96. What is the ratio of the Exports (in Local Currency Unit) in Denmark in 1998 to that in 1999?
Offer a very short reply. 0.9. What is the ratio of the Exports (in Local Currency Unit) of Poland in 1998 to that in 1999?
Provide a succinct answer. 0.97. What is the ratio of the Exports (in Local Currency Unit) of Congo (Republic) in 1998 to that in 2000?
Provide a short and direct response. 0.48. What is the ratio of the Exports (in Local Currency Unit) of Cyprus in 1998 to that in 2000?
Keep it short and to the point. 0.84. What is the ratio of the Exports (in Local Currency Unit) of Denmark in 1998 to that in 2000?
Ensure brevity in your answer.  0.74. What is the ratio of the Exports (in Local Currency Unit) of Poland in 1998 to that in 2000?
Your answer should be very brief. 0.77. What is the ratio of the Exports (in Local Currency Unit) in Congo (Republic) in 1998 to that in 2001?
Keep it short and to the point. 0.55. What is the ratio of the Exports (in Local Currency Unit) of Cyprus in 1998 to that in 2001?
Ensure brevity in your answer.  0.8. What is the ratio of the Exports (in Local Currency Unit) in Denmark in 1998 to that in 2001?
Your answer should be compact. 0.71. What is the ratio of the Exports (in Local Currency Unit) in Poland in 1998 to that in 2001?
Offer a terse response. 0.74. What is the ratio of the Exports (in Local Currency Unit) in Congo (Republic) in 1998 to that in 2002?
Your answer should be compact. 0.51. What is the ratio of the Exports (in Local Currency Unit) of Cyprus in 1998 to that in 2002?
Keep it short and to the point. 0.84. What is the ratio of the Exports (in Local Currency Unit) in Denmark in 1998 to that in 2002?
Your answer should be compact. 0.69. What is the ratio of the Exports (in Local Currency Unit) of Poland in 1998 to that in 2002?
Your answer should be compact. 0.67. What is the ratio of the Exports (in Local Currency Unit) of Congo (Republic) in 1998 to that in 2003?
Provide a succinct answer. 0.53. What is the ratio of the Exports (in Local Currency Unit) in Cyprus in 1998 to that in 2003?
Make the answer very short. 0.84. What is the ratio of the Exports (in Local Currency Unit) of Denmark in 1998 to that in 2003?
Your answer should be very brief. 0.7. What is the ratio of the Exports (in Local Currency Unit) of Poland in 1998 to that in 2003?
Provide a succinct answer. 0.56. What is the ratio of the Exports (in Local Currency Unit) of Congo (Republic) in 1999 to that in 2000?
Provide a short and direct response. 0.57. What is the ratio of the Exports (in Local Currency Unit) of Cyprus in 1999 to that in 2000?
Your answer should be compact. 0.88. What is the ratio of the Exports (in Local Currency Unit) in Denmark in 1999 to that in 2000?
Your response must be concise. 0.82. What is the ratio of the Exports (in Local Currency Unit) of Poland in 1999 to that in 2000?
Provide a succinct answer. 0.8. What is the ratio of the Exports (in Local Currency Unit) in Congo (Republic) in 1999 to that in 2001?
Keep it short and to the point. 0.66. What is the ratio of the Exports (in Local Currency Unit) in Cyprus in 1999 to that in 2001?
Your response must be concise. 0.84. What is the ratio of the Exports (in Local Currency Unit) of Denmark in 1999 to that in 2001?
Your answer should be compact. 0.78. What is the ratio of the Exports (in Local Currency Unit) of Poland in 1999 to that in 2001?
Provide a short and direct response. 0.76. What is the ratio of the Exports (in Local Currency Unit) in Congo (Republic) in 1999 to that in 2002?
Your response must be concise. 0.61. What is the ratio of the Exports (in Local Currency Unit) of Cyprus in 1999 to that in 2002?
Provide a succinct answer. 0.88. What is the ratio of the Exports (in Local Currency Unit) in Denmark in 1999 to that in 2002?
Provide a short and direct response. 0.76. What is the ratio of the Exports (in Local Currency Unit) of Poland in 1999 to that in 2002?
Your response must be concise. 0.7. What is the ratio of the Exports (in Local Currency Unit) in Congo (Republic) in 1999 to that in 2003?
Keep it short and to the point. 0.64. What is the ratio of the Exports (in Local Currency Unit) in Cyprus in 1999 to that in 2003?
Keep it short and to the point. 0.88. What is the ratio of the Exports (in Local Currency Unit) of Denmark in 1999 to that in 2003?
Provide a succinct answer. 0.78. What is the ratio of the Exports (in Local Currency Unit) of Poland in 1999 to that in 2003?
Your answer should be compact. 0.57. What is the ratio of the Exports (in Local Currency Unit) of Congo (Republic) in 2000 to that in 2001?
Make the answer very short. 1.16. What is the ratio of the Exports (in Local Currency Unit) of Cyprus in 2000 to that in 2001?
Your response must be concise. 0.95. What is the ratio of the Exports (in Local Currency Unit) of Denmark in 2000 to that in 2001?
Offer a very short reply. 0.95. What is the ratio of the Exports (in Local Currency Unit) of Poland in 2000 to that in 2001?
Ensure brevity in your answer.  0.96. What is the ratio of the Exports (in Local Currency Unit) in Congo (Republic) in 2000 to that in 2002?
Offer a terse response. 1.07. What is the ratio of the Exports (in Local Currency Unit) in Denmark in 2000 to that in 2002?
Provide a succinct answer. 0.93. What is the ratio of the Exports (in Local Currency Unit) in Poland in 2000 to that in 2002?
Offer a terse response. 0.87. What is the ratio of the Exports (in Local Currency Unit) of Congo (Republic) in 2000 to that in 2003?
Make the answer very short. 1.12. What is the ratio of the Exports (in Local Currency Unit) in Denmark in 2000 to that in 2003?
Make the answer very short. 0.94. What is the ratio of the Exports (in Local Currency Unit) of Poland in 2000 to that in 2003?
Offer a terse response. 0.72. What is the ratio of the Exports (in Local Currency Unit) in Congo (Republic) in 2001 to that in 2002?
Provide a short and direct response. 0.92. What is the ratio of the Exports (in Local Currency Unit) in Cyprus in 2001 to that in 2002?
Give a very brief answer. 1.05. What is the ratio of the Exports (in Local Currency Unit) in Denmark in 2001 to that in 2002?
Your answer should be compact. 0.98. What is the ratio of the Exports (in Local Currency Unit) in Poland in 2001 to that in 2002?
Ensure brevity in your answer.  0.91. What is the ratio of the Exports (in Local Currency Unit) of Congo (Republic) in 2001 to that in 2003?
Keep it short and to the point. 0.97. What is the ratio of the Exports (in Local Currency Unit) of Cyprus in 2001 to that in 2003?
Your answer should be very brief. 1.05. What is the ratio of the Exports (in Local Currency Unit) of Denmark in 2001 to that in 2003?
Provide a succinct answer. 0.99. What is the ratio of the Exports (in Local Currency Unit) of Poland in 2001 to that in 2003?
Provide a succinct answer. 0.75. What is the ratio of the Exports (in Local Currency Unit) in Congo (Republic) in 2002 to that in 2003?
Provide a short and direct response. 1.04. What is the ratio of the Exports (in Local Currency Unit) of Cyprus in 2002 to that in 2003?
Offer a terse response. 1. What is the ratio of the Exports (in Local Currency Unit) of Denmark in 2002 to that in 2003?
Provide a succinct answer. 1.02. What is the ratio of the Exports (in Local Currency Unit) of Poland in 2002 to that in 2003?
Provide a short and direct response. 0.83. What is the difference between the highest and the second highest Exports (in Local Currency Unit) in Congo (Republic)?
Keep it short and to the point. 1.25e+11. What is the difference between the highest and the second highest Exports (in Local Currency Unit) of Cyprus?
Ensure brevity in your answer.  3.68e+08. What is the difference between the highest and the second highest Exports (in Local Currency Unit) of Denmark?
Keep it short and to the point. 9.83e+09. What is the difference between the highest and the second highest Exports (in Local Currency Unit) of Poland?
Make the answer very short. 4.93e+1. What is the difference between the highest and the lowest Exports (in Local Currency Unit) of Congo (Republic)?
Your answer should be very brief. 9.64e+11. What is the difference between the highest and the lowest Exports (in Local Currency Unit) in Cyprus?
Offer a very short reply. 1.99e+09. What is the difference between the highest and the lowest Exports (in Local Currency Unit) of Denmark?
Offer a very short reply. 2.07e+11. What is the difference between the highest and the lowest Exports (in Local Currency Unit) of Poland?
Offer a very short reply. 1.61e+11. 